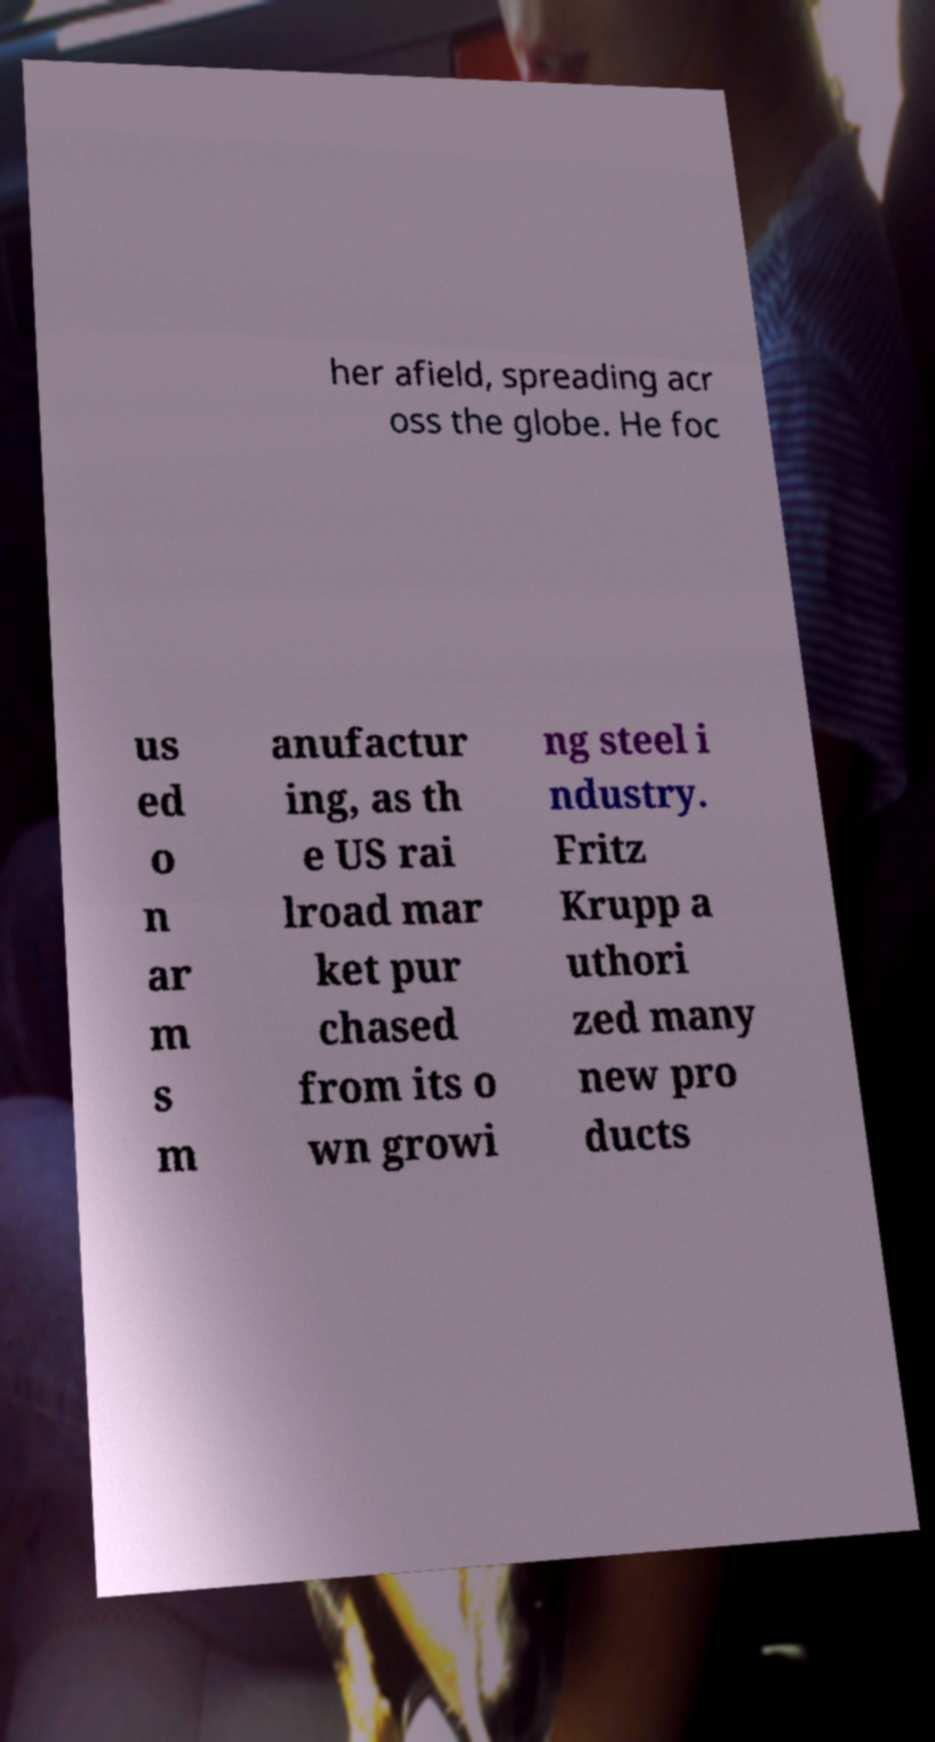I need the written content from this picture converted into text. Can you do that? her afield, spreading acr oss the globe. He foc us ed o n ar m s m anufactur ing, as th e US rai lroad mar ket pur chased from its o wn growi ng steel i ndustry. Fritz Krupp a uthori zed many new pro ducts 